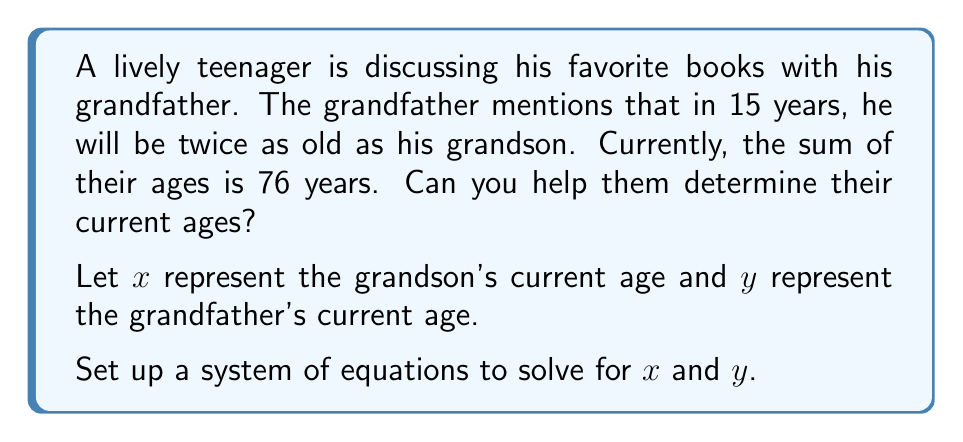Provide a solution to this math problem. Let's approach this step-by-step:

1) First, let's define our variables:
   $x$ = grandson's current age
   $y$ = grandfather's current age

2) Now, let's set up our system of equations based on the given information:

   Equation 1: The sum of their current ages is 76
   $$x + y = 76$$

   Equation 2: In 15 years, the grandfather will be twice as old as the grandson
   $$(y + 15) = 2(x + 15)$$

3) Let's solve this system by substitution:

4) From Equation 2:
   $$y + 15 = 2x + 30$$
   $$y = 2x + 15$$

5) Substitute this into Equation 1:
   $$x + (2x + 15) = 76$$
   $$3x + 15 = 76$$
   $$3x = 61$$
   $$x = \frac{61}{3} \approx 20.33$$

6) Since age is typically expressed in whole numbers, we'll round down to 20.

7) Now that we know $x = 20$, we can find $y$ using either of our original equations. Let's use Equation 1:
   $$20 + y = 76$$
   $$y = 56$$

8) Let's verify using Equation 2:
   $$(56 + 15) = 2(20 + 15)$$
   $$71 = 2(35)$$
   $$71 = 70$$ (This small discrepancy is due to rounding $x$ down to 20)

Therefore, the grandson is currently 20 years old, and the grandfather is 56 years old.
Answer: Grandson's current age: 20 years
Grandfather's current age: 56 years 